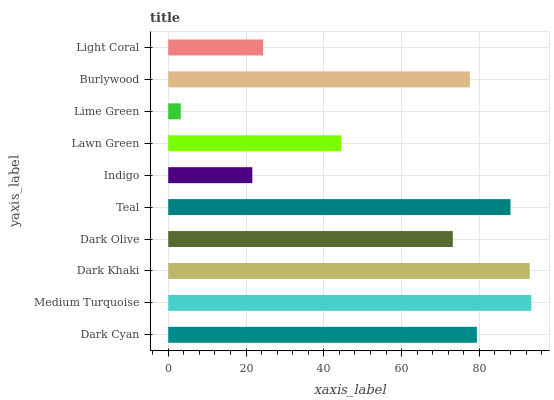Is Lime Green the minimum?
Answer yes or no. Yes. Is Medium Turquoise the maximum?
Answer yes or no. Yes. Is Dark Khaki the minimum?
Answer yes or no. No. Is Dark Khaki the maximum?
Answer yes or no. No. Is Medium Turquoise greater than Dark Khaki?
Answer yes or no. Yes. Is Dark Khaki less than Medium Turquoise?
Answer yes or no. Yes. Is Dark Khaki greater than Medium Turquoise?
Answer yes or no. No. Is Medium Turquoise less than Dark Khaki?
Answer yes or no. No. Is Burlywood the high median?
Answer yes or no. Yes. Is Dark Olive the low median?
Answer yes or no. Yes. Is Lime Green the high median?
Answer yes or no. No. Is Lawn Green the low median?
Answer yes or no. No. 